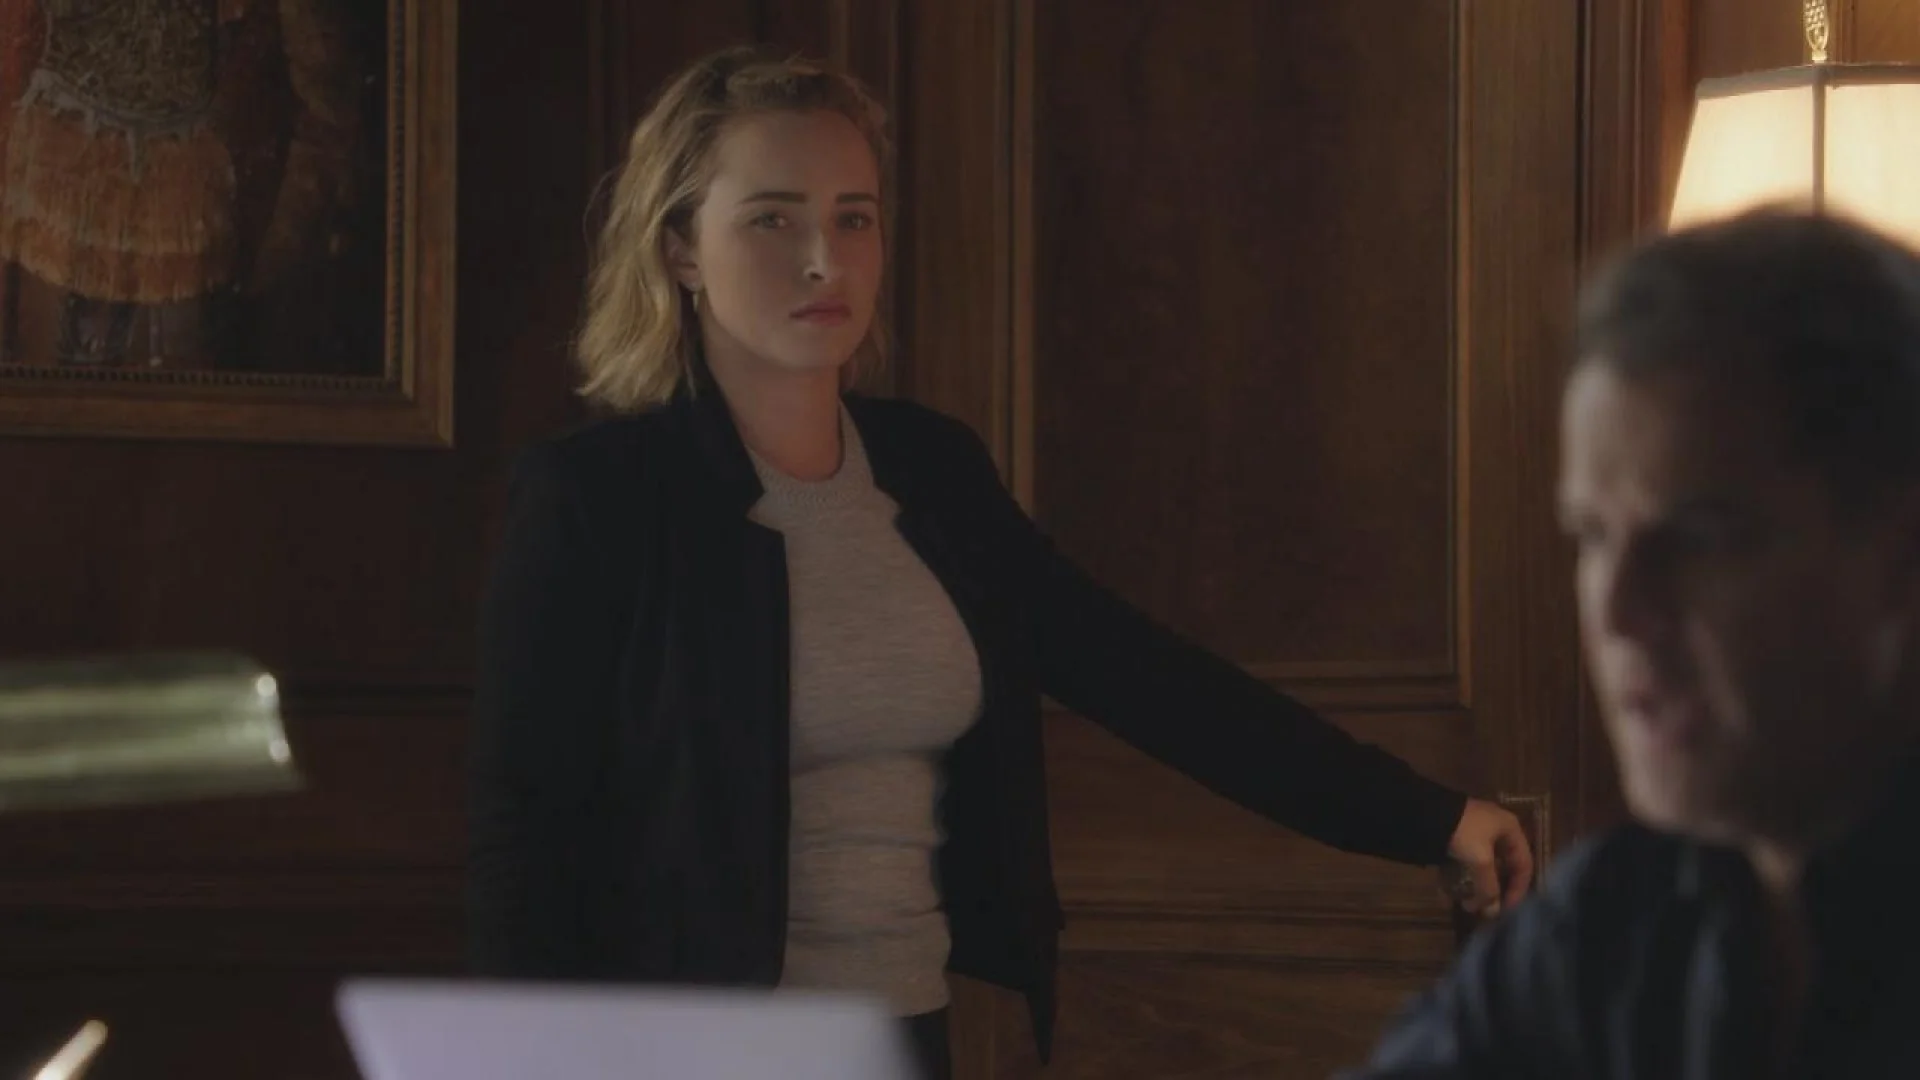Can you elaborate on the elements of the picture provided? In the image, a woman is captured in a moment of significant interaction. She is dressed in a professional manner, wearing a black blazer over a gray top. The context appears serious, highlighted by her focused expression and pointed gesture. She is standing in a dimly lit room, characteristic of a traditional office or study, with the only other visible element being a heavily blurred male figure seated at a wooden desk. A lamp provides a soft glow, which adds to the dramatic ambiance of the scene, emphasizing the seriousness of the conversation or confrontation. 